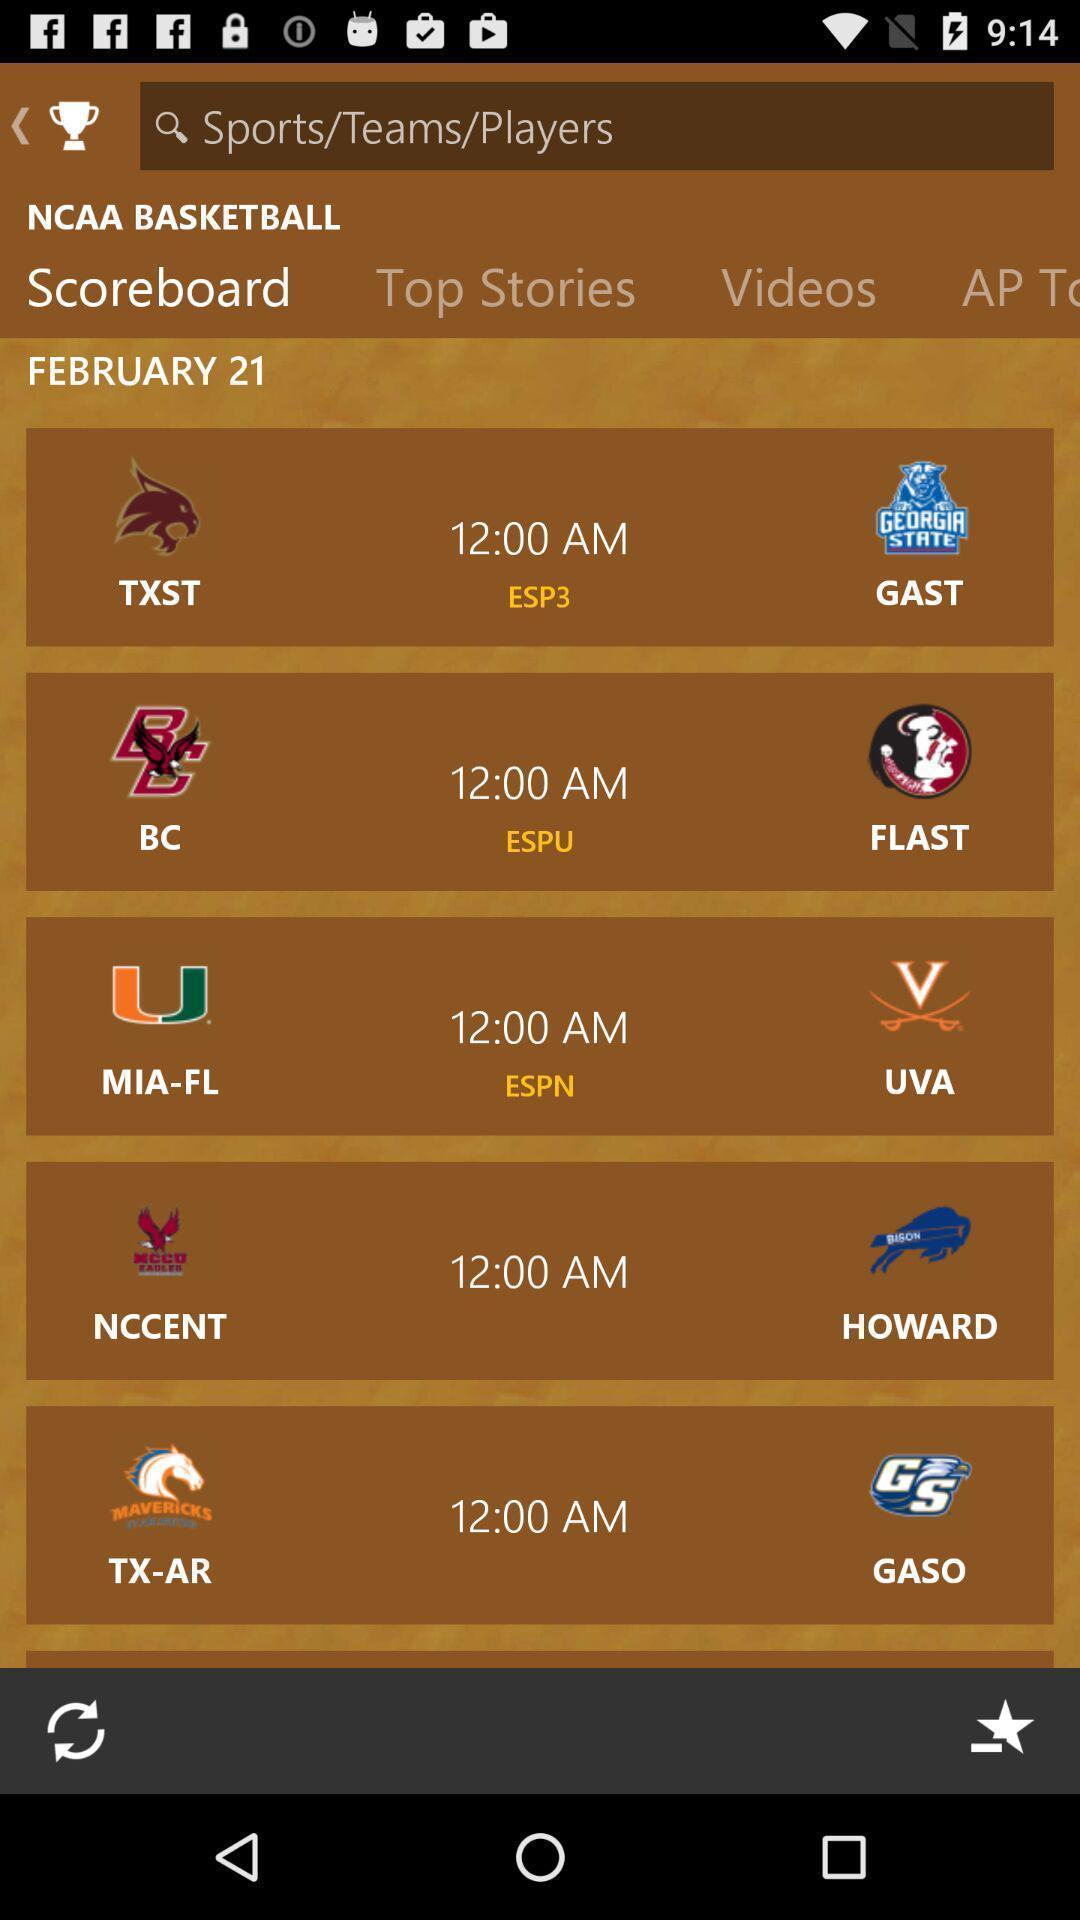Provide a textual representation of this image. Teams are displaying for a specific date. 